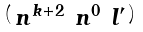Convert formula to latex. <formula><loc_0><loc_0><loc_500><loc_500>\begin{psmallmatrix} n ^ { k + 2 } & n ^ { 0 } & l ^ { \prime } \end{psmallmatrix}</formula> 